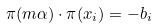<formula> <loc_0><loc_0><loc_500><loc_500>\pi ( m \alpha ) \cdot \pi ( x _ { i } ) = - b _ { i }</formula> 